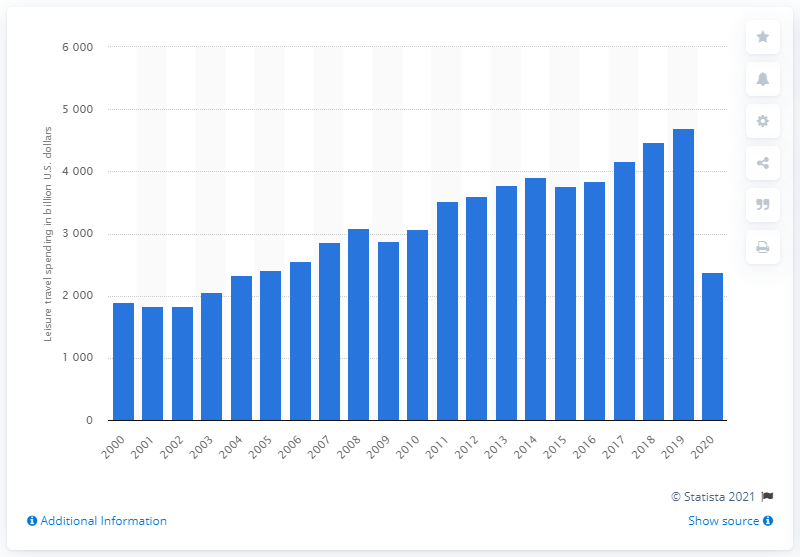Specify some key components in this picture. In 2020, global leisure travel expenditure was $2,373. In 2019, global leisure travel spending was estimated to be approximately 4692. 